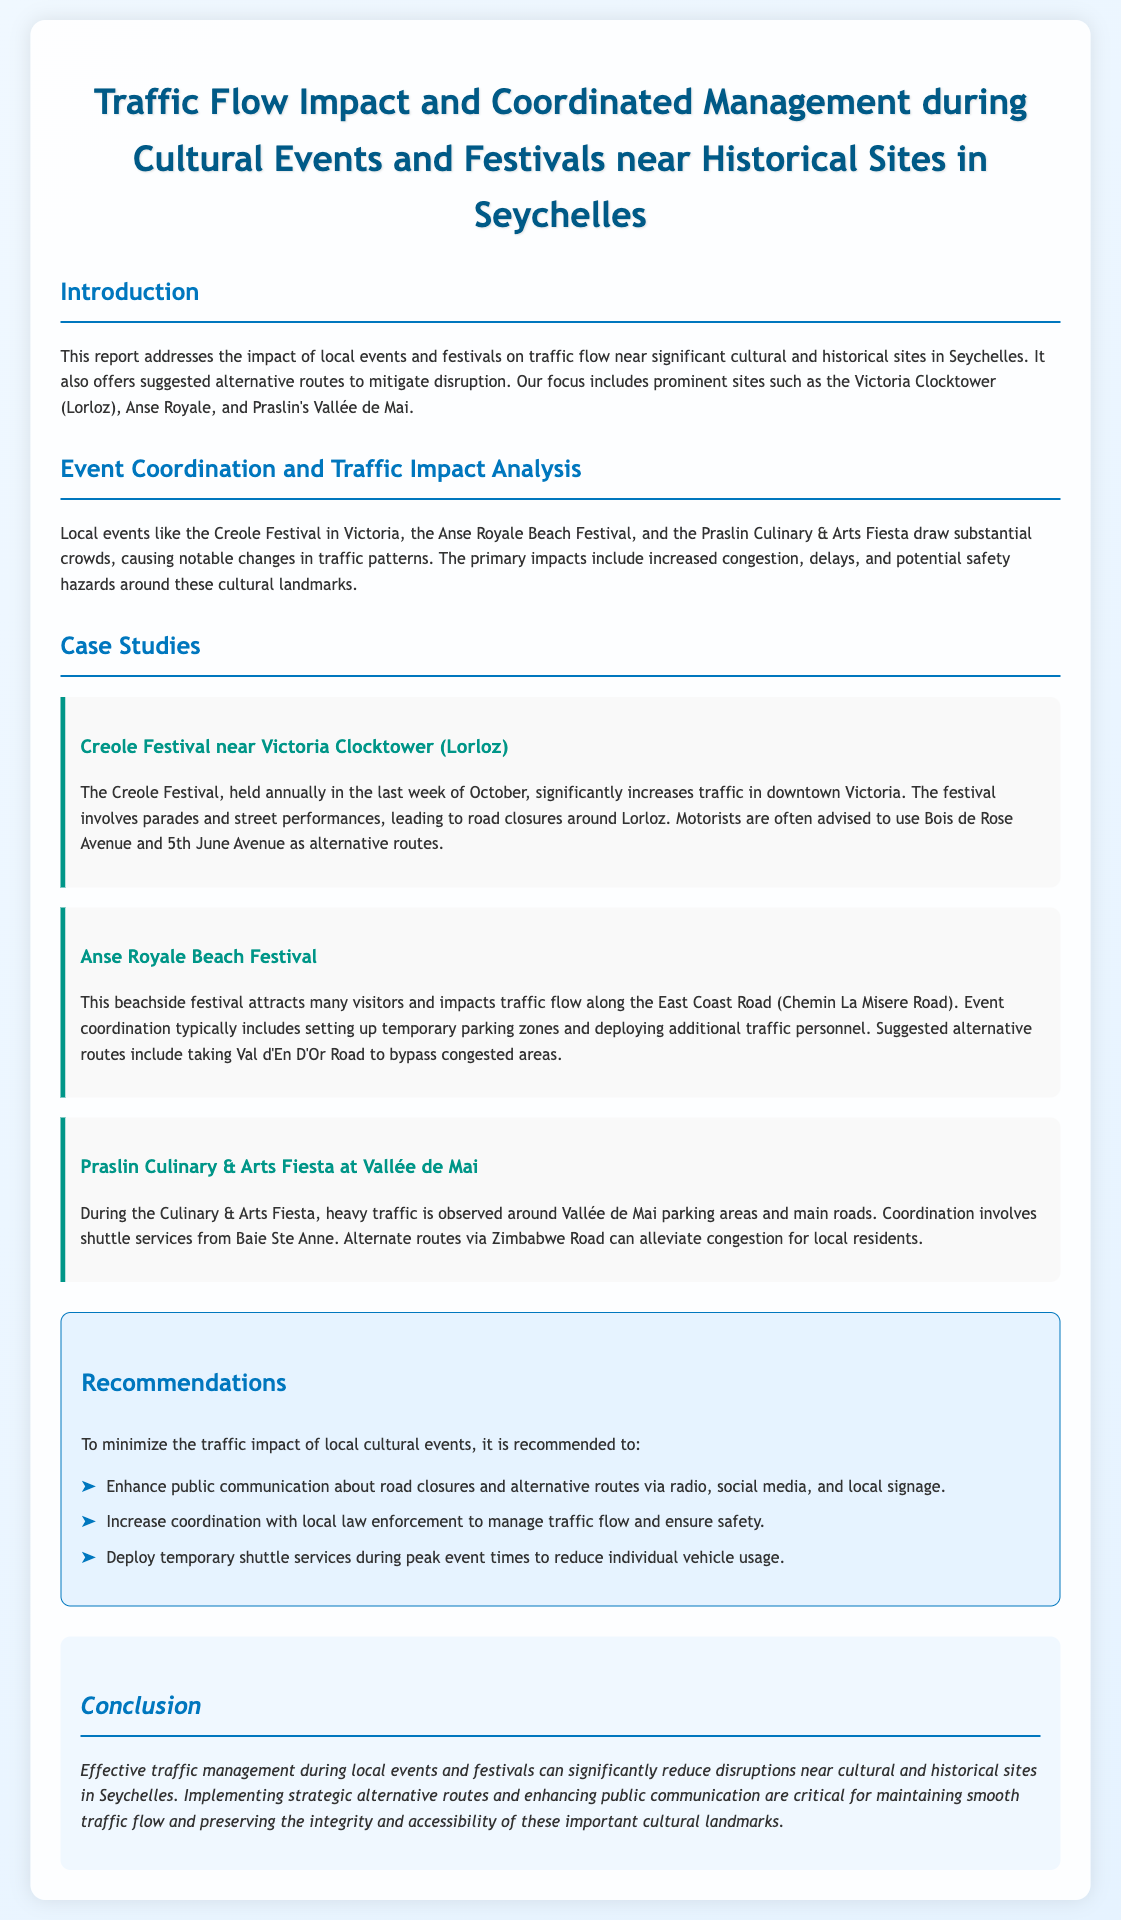What is the title of the report? The title of the report is presented at the top of the document and is "Traffic Flow Impact and Coordinated Management during Cultural Events and Festivals near Historical Sites in Seychelles."
Answer: Traffic Flow Impact and Coordinated Management during Cultural Events and Festivals near Historical Sites in Seychelles What event occurs annually in the last week of October? The document details the Creole Festival, which is held annually in the last week of October near Victoria Clocktower.
Answer: Creole Festival Which two roads are suggested alternative routes during the Creole Festival? The report mentions Bois de Rose Avenue and 5th June Avenue as alternative routes for the Creole Festival.
Answer: Bois de Rose Avenue and 5th June Avenue What festival impacts traffic along the East Coast Road? The Anse Royale Beach Festival, as mentioned in the document, significantly impacts traffic along the East Coast Road.
Answer: Anse Royale Beach Festival What is one recommendation to minimize traffic impact? The report suggests enhancing public communication about road closures and alternative routes.
Answer: Enhance public communication What is one way to alleviate congestion during the Praslin Culinary & Arts Fiesta? The document suggests using alternate routes via Zimbabwe Road to alleviate congestion for local residents during the fiesta.
Answer: Zimbabwe Road How many case studies are mentioned in the report? The report outlines three case studies, each detailing a specific local event's impact on traffic.
Answer: Three What is the focus of the report? The report focuses on the impact of local events and festivals on traffic flow near significant cultural and historical sites.
Answer: Impact of local events and festivals on traffic flow 